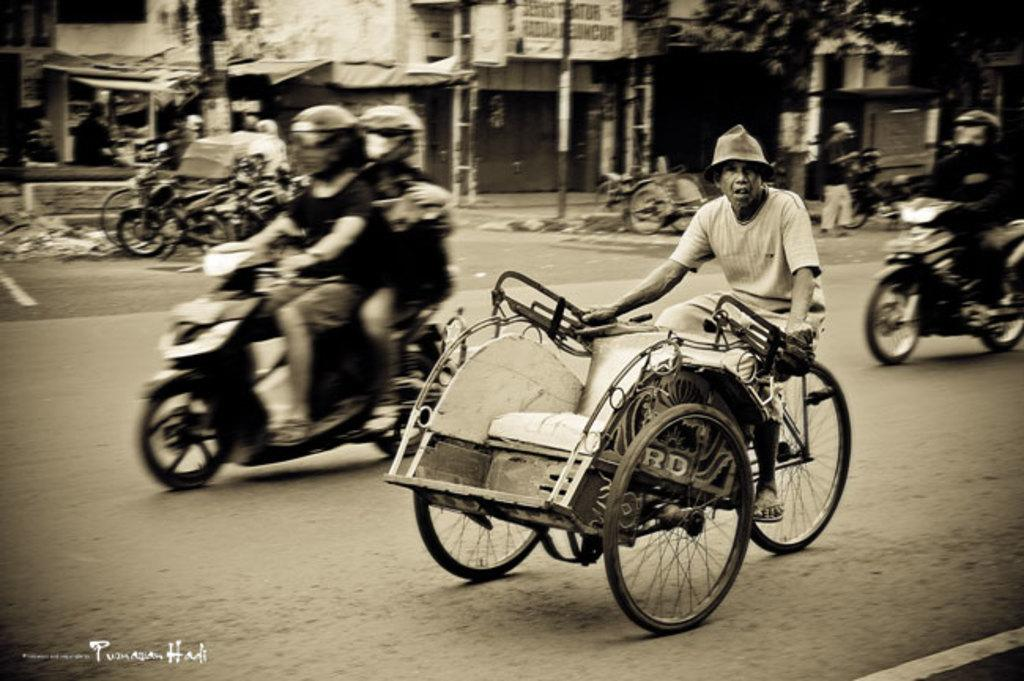What is the time period depicted in the image? The image depicts a scene from a long time ago. What can be seen on the road in the image? There are vehicles running on the road. What is located on the left side of the image? There are houses, trees, and sheds on the left side of the image. What type of juice can be seen flowing in the river in the image? There is no river present in the image, and therefore no juice flowing in it. What is the writing on the sheds in the image? There is no writing visible on the sheds in the image. 